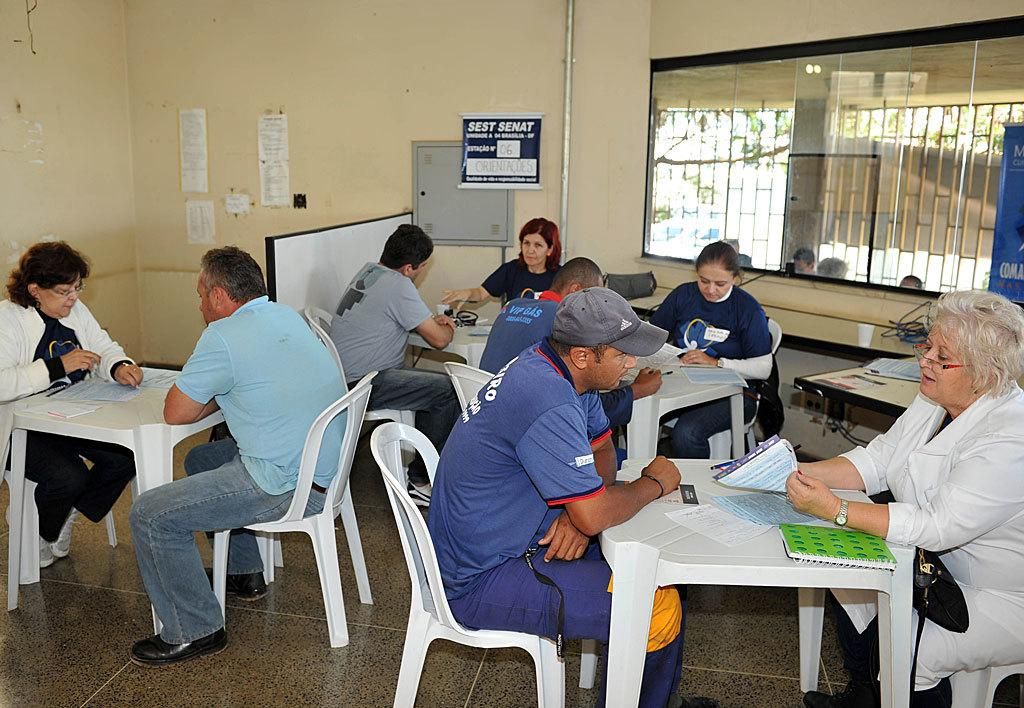What are the people in the image doing? There is a group of people sitting on chairs in the image. What is in front of the chairs? There is a table in front of the chairs. What items can be seen on the table? There are books and papers on the table. What can be seen in the room besides the table and chairs? There is a window and a wall in the room. What type of marble is being used as a toy by the people in the image? There is no marble or toy present in the image; the people are sitting on chairs and there are books and papers on the table. 